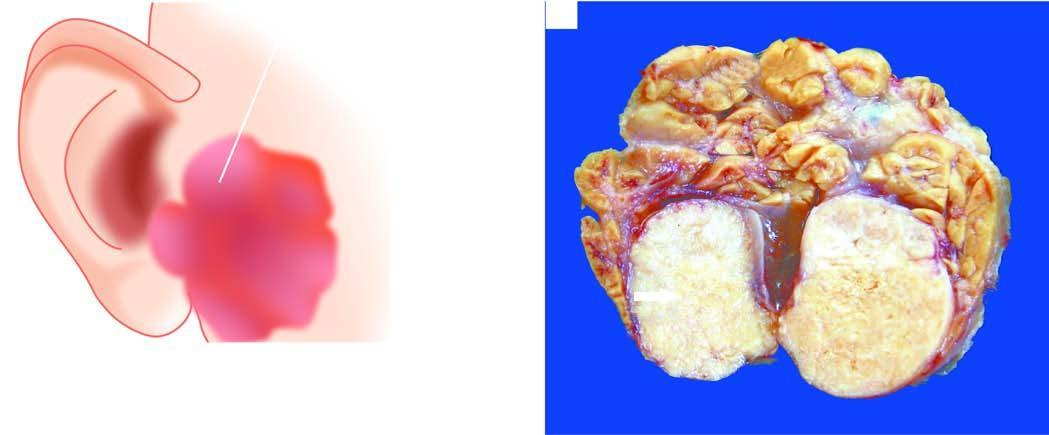what does sectioned surface of the parotid gland show?
Answer the question using a single word or phrase. Lobules of grey-white circumscribed tumour having semitranslucent parenchyma 